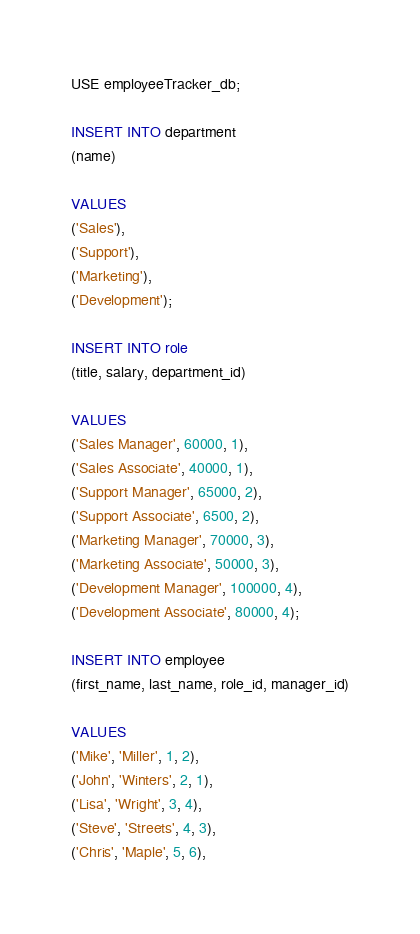Convert code to text. <code><loc_0><loc_0><loc_500><loc_500><_SQL_>USE employeeTracker_db;

INSERT INTO department
(name)

VALUES
('Sales'),
('Support'),
('Marketing'),
('Development');

INSERT INTO role 
(title, salary, department_id)

VALUES
('Sales Manager', 60000, 1),
('Sales Associate', 40000, 1),
('Support Manager', 65000, 2),
('Support Associate', 6500, 2),
('Marketing Manager', 70000, 3),
('Marketing Associate', 50000, 3),
('Development Manager', 100000, 4),
('Development Associate', 80000, 4);

INSERT INTO employee
(first_name, last_name, role_id, manager_id)

VALUES
('Mike', 'Miller', 1, 2),
('John', 'Winters', 2, 1),
('Lisa', 'Wright', 3, 4),
('Steve', 'Streets', 4, 3),
('Chris', 'Maple', 5, 6),</code> 